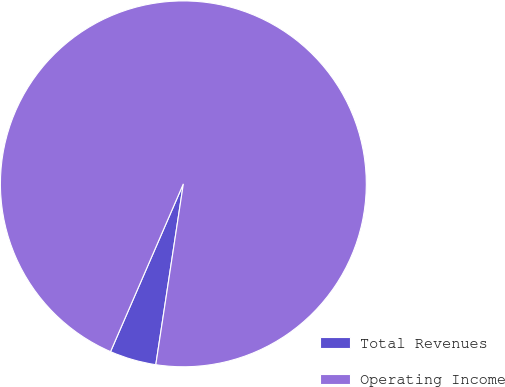<chart> <loc_0><loc_0><loc_500><loc_500><pie_chart><fcel>Total Revenues<fcel>Operating Income<nl><fcel>4.11%<fcel>95.89%<nl></chart> 